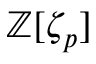<formula> <loc_0><loc_0><loc_500><loc_500>\mathbb { Z } [ \zeta _ { p } ]</formula> 